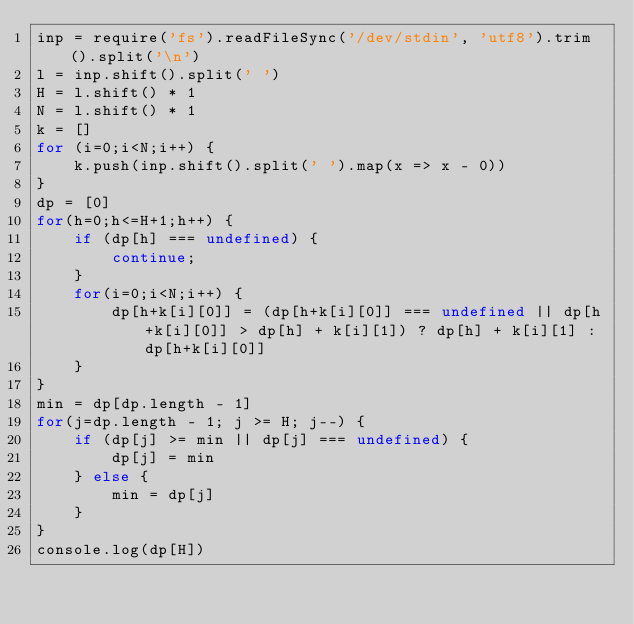<code> <loc_0><loc_0><loc_500><loc_500><_JavaScript_>inp = require('fs').readFileSync('/dev/stdin', 'utf8').trim().split('\n')
l = inp.shift().split(' ')
H = l.shift() * 1
N = l.shift() * 1
k = []
for (i=0;i<N;i++) {
    k.push(inp.shift().split(' ').map(x => x - 0))
}
dp = [0]
for(h=0;h<=H+1;h++) {
    if (dp[h] === undefined) {
        continue;
    }
    for(i=0;i<N;i++) {
        dp[h+k[i][0]] = (dp[h+k[i][0]] === undefined || dp[h+k[i][0]] > dp[h] + k[i][1]) ? dp[h] + k[i][1] : dp[h+k[i][0]]
    }
}
min = dp[dp.length - 1]
for(j=dp.length - 1; j >= H; j--) {
    if (dp[j] >= min || dp[j] === undefined) {
        dp[j] = min
    } else {
        min = dp[j]
    }
}
console.log(dp[H])

</code> 